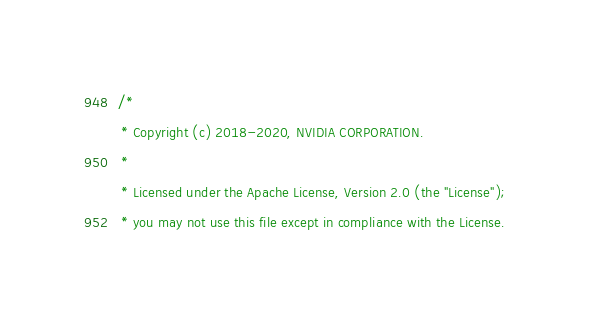<code> <loc_0><loc_0><loc_500><loc_500><_Cuda_>/*
 * Copyright (c) 2018-2020, NVIDIA CORPORATION.
 *
 * Licensed under the Apache License, Version 2.0 (the "License");
 * you may not use this file except in compliance with the License.</code> 